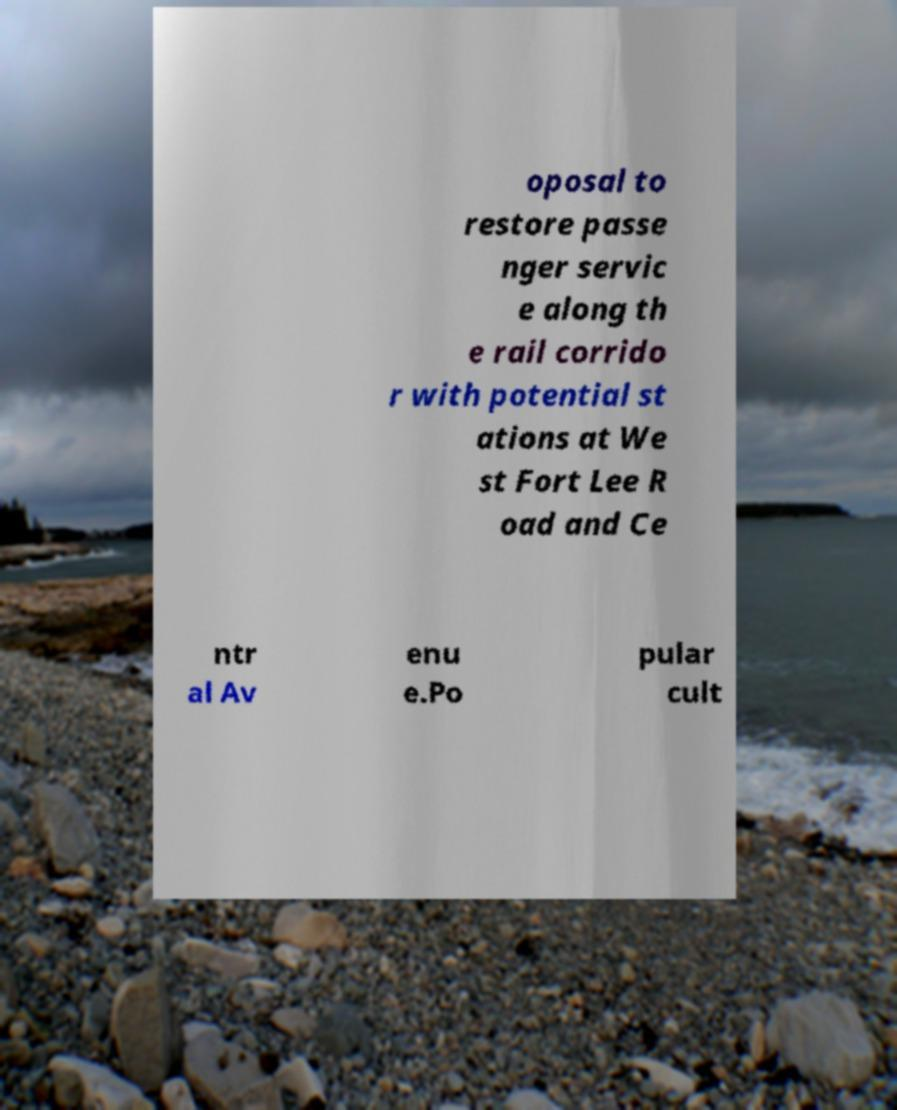Could you assist in decoding the text presented in this image and type it out clearly? oposal to restore passe nger servic e along th e rail corrido r with potential st ations at We st Fort Lee R oad and Ce ntr al Av enu e.Po pular cult 